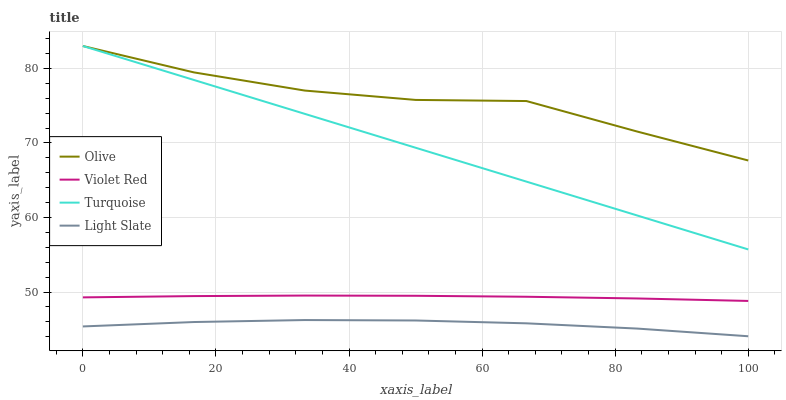Does Light Slate have the minimum area under the curve?
Answer yes or no. Yes. Does Olive have the maximum area under the curve?
Answer yes or no. Yes. Does Violet Red have the minimum area under the curve?
Answer yes or no. No. Does Violet Red have the maximum area under the curve?
Answer yes or no. No. Is Turquoise the smoothest?
Answer yes or no. Yes. Is Olive the roughest?
Answer yes or no. Yes. Is Light Slate the smoothest?
Answer yes or no. No. Is Light Slate the roughest?
Answer yes or no. No. Does Light Slate have the lowest value?
Answer yes or no. Yes. Does Violet Red have the lowest value?
Answer yes or no. No. Does Turquoise have the highest value?
Answer yes or no. Yes. Does Violet Red have the highest value?
Answer yes or no. No. Is Light Slate less than Turquoise?
Answer yes or no. Yes. Is Violet Red greater than Light Slate?
Answer yes or no. Yes. Does Olive intersect Turquoise?
Answer yes or no. Yes. Is Olive less than Turquoise?
Answer yes or no. No. Is Olive greater than Turquoise?
Answer yes or no. No. Does Light Slate intersect Turquoise?
Answer yes or no. No. 